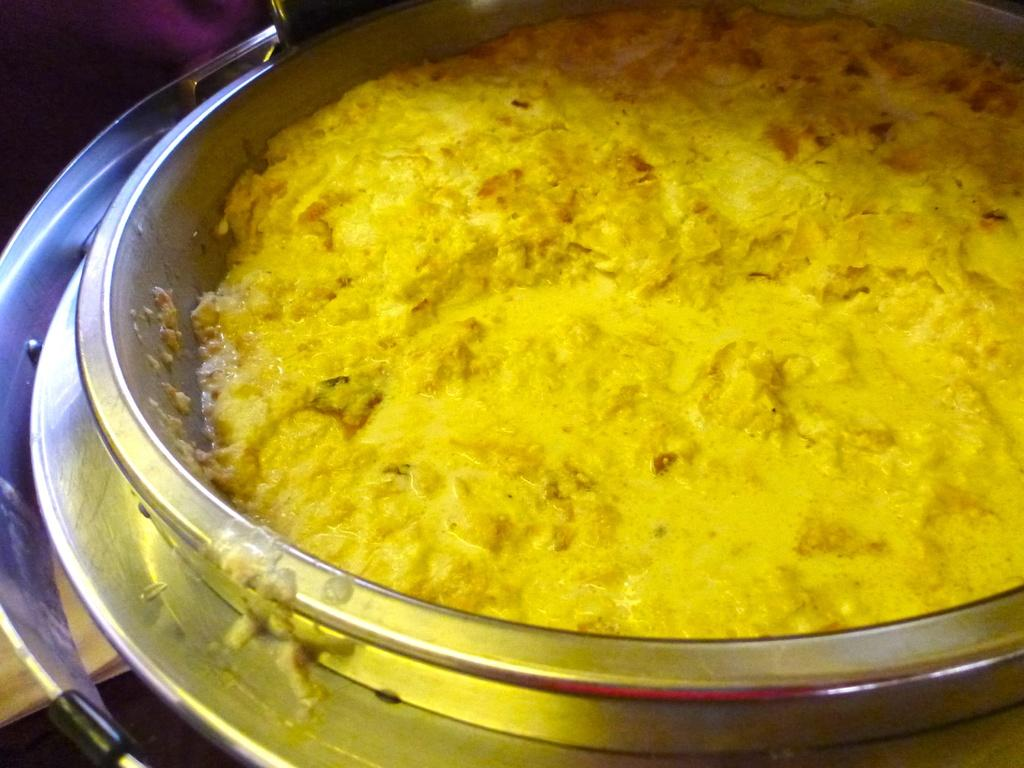What is the main subject of the image? The main subject of the image is food. What type of container is present in the image? There is a container in the image. Can you describe any other objects in the image besides the food and container? There are unspecified objects in the image. What type of tiger is sitting on the stove in the image? There is no tiger or stove present in the image. What type of beef is being cooked on the stove in the image? There is no beef or stove present in the image. 